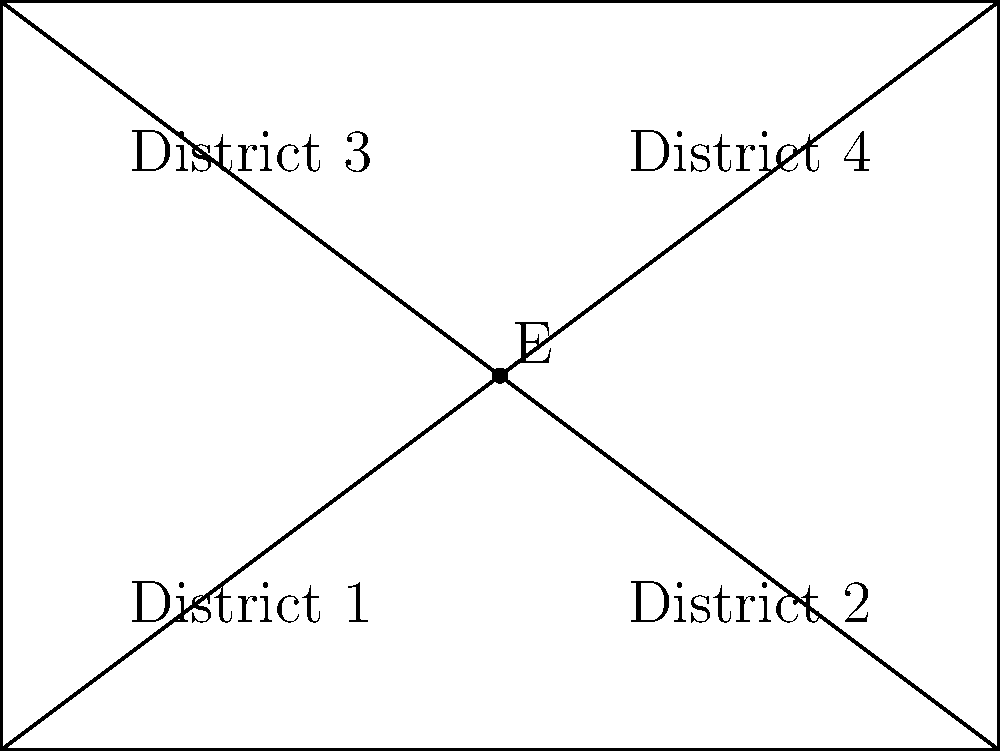In a rectangular city divided into four districts as shown, a new redistricting plan is proposed. The plan involves moving point E, which currently divides the city into four equal-area districts. If E is shifted 0.5 units to the right, calculate the efficiency gap of the new districting plan, assuming Party A wins districts with more than 50% of their area and Party B wins the rest. The efficiency gap is defined as the difference between the parties' respective wasted votes, divided by the total number of votes cast. Let's approach this step-by-step:

1) First, calculate the areas of each district after moving E:
   - Total area of the city: $4 * 3 = 12$ square units
   - New coordinates of E: (2.5, 1.5)
   - Area of District 1: $2.5 * 1.5 = 3.75$ sq units
   - Area of District 2: $1.5 * 1.5 = 2.25$ sq units
   - Area of District 3: $2.5 * 1.5 = 3.75$ sq units
   - Area of District 4: $1.5 * 1.5 = 2.25$ sq units

2) Determine which party wins each district:
   - Party A wins Districts 1 and 3 (area > 3 sq units)
   - Party B wins Districts 2 and 4 (area < 3 sq units)

3) Calculate wasted votes for each party:
   - Party A wasted votes: 
     In Districts 1 and 3: $(3.75 - 3) * 2 = 1.5$
     In Districts 2 and 4: $2.25 * 2 = 4.5$
     Total: $1.5 + 4.5 = 6$
   - Party B wasted votes:
     In Districts 1 and 3: $3.75 * 2 = 7.5$
     In Districts 2 and 4: $(2.25 - 1.5) * 2 = 1.5$
     Total: $7.5 + 1.5 = 9$

4) Calculate the efficiency gap:
   Efficiency Gap = $\frac{|Party A wasted votes - Party B wasted votes|}{Total votes}$
   $= \frac{|6 - 9|}{12} = \frac{3}{12} = 0.25$ or 25%
Answer: 25% 